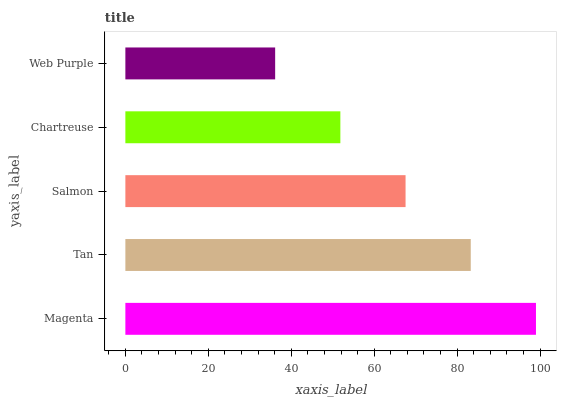Is Web Purple the minimum?
Answer yes or no. Yes. Is Magenta the maximum?
Answer yes or no. Yes. Is Tan the minimum?
Answer yes or no. No. Is Tan the maximum?
Answer yes or no. No. Is Magenta greater than Tan?
Answer yes or no. Yes. Is Tan less than Magenta?
Answer yes or no. Yes. Is Tan greater than Magenta?
Answer yes or no. No. Is Magenta less than Tan?
Answer yes or no. No. Is Salmon the high median?
Answer yes or no. Yes. Is Salmon the low median?
Answer yes or no. Yes. Is Magenta the high median?
Answer yes or no. No. Is Magenta the low median?
Answer yes or no. No. 